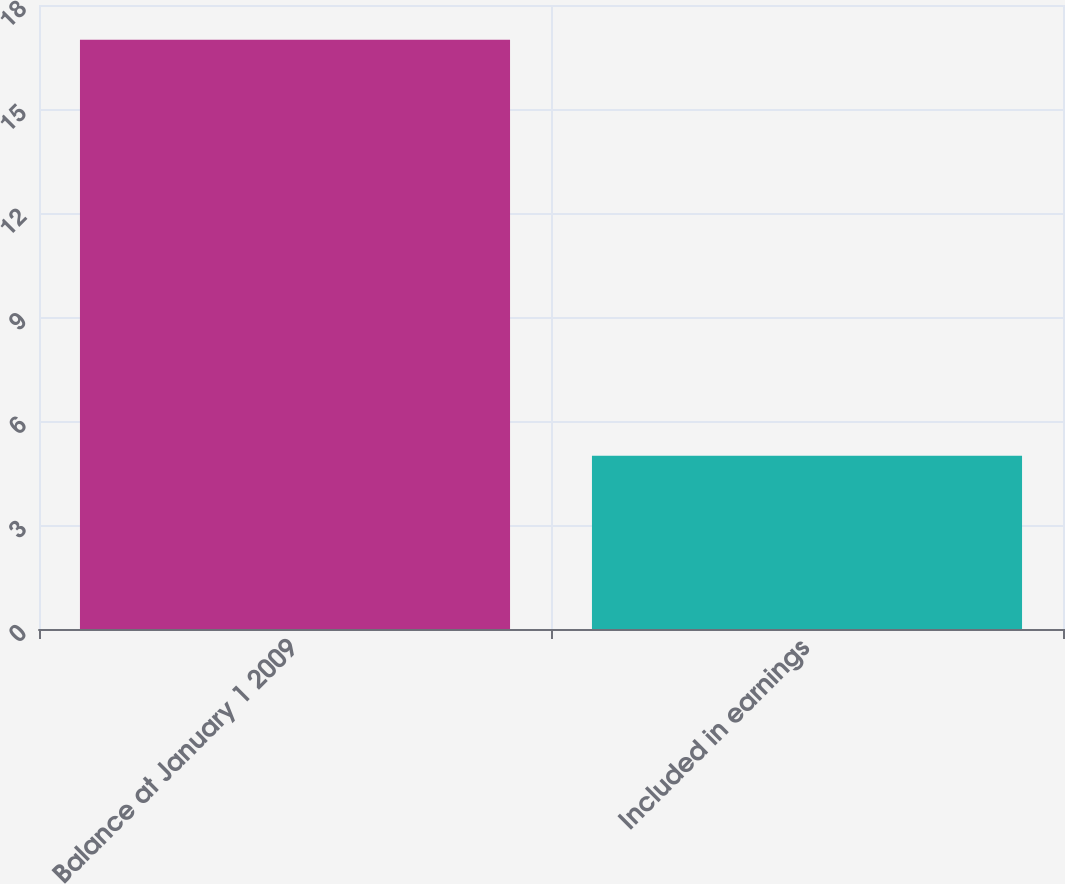Convert chart. <chart><loc_0><loc_0><loc_500><loc_500><bar_chart><fcel>Balance at January 1 2009<fcel>Included in earnings<nl><fcel>17<fcel>5<nl></chart> 